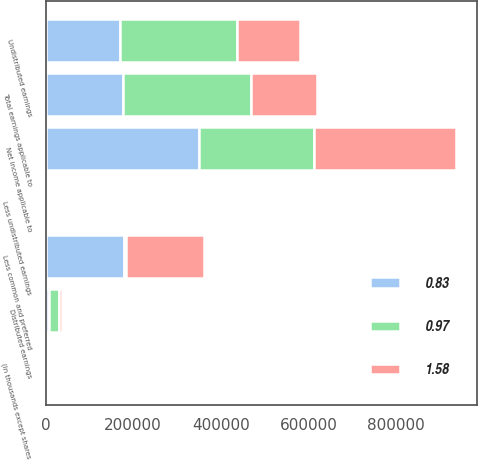<chart> <loc_0><loc_0><loc_500><loc_500><stacked_bar_chart><ecel><fcel>(In thousands except shares<fcel>Net income applicable to<fcel>Less common and preferred<fcel>Undistributed earnings<fcel>Less undistributed earnings<fcel>Distributed earnings<fcel>Total earnings applicable to<nl><fcel>0.97<fcel>2013<fcel>263791<fcel>6094<fcel>267053<fcel>2832<fcel>23916<fcel>290969<nl><fcel>0.83<fcel>2012<fcel>349516<fcel>178277<fcel>169639<fcel>1600<fcel>7321<fcel>176960<nl><fcel>1.58<fcel>2011<fcel>323804<fcel>177775<fcel>144729<fcel>1300<fcel>7292<fcel>152021<nl></chart> 